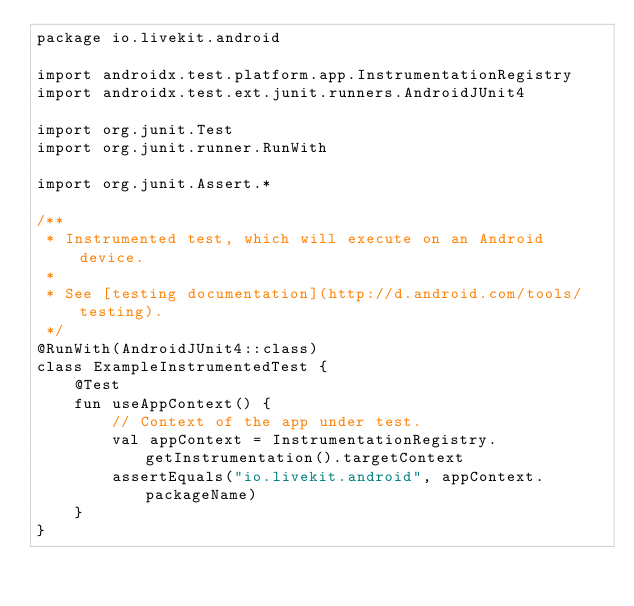<code> <loc_0><loc_0><loc_500><loc_500><_Kotlin_>package io.livekit.android

import androidx.test.platform.app.InstrumentationRegistry
import androidx.test.ext.junit.runners.AndroidJUnit4

import org.junit.Test
import org.junit.runner.RunWith

import org.junit.Assert.*

/**
 * Instrumented test, which will execute on an Android device.
 *
 * See [testing documentation](http://d.android.com/tools/testing).
 */
@RunWith(AndroidJUnit4::class)
class ExampleInstrumentedTest {
    @Test
    fun useAppContext() {
        // Context of the app under test.
        val appContext = InstrumentationRegistry.getInstrumentation().targetContext
        assertEquals("io.livekit.android", appContext.packageName)
    }
}
</code> 